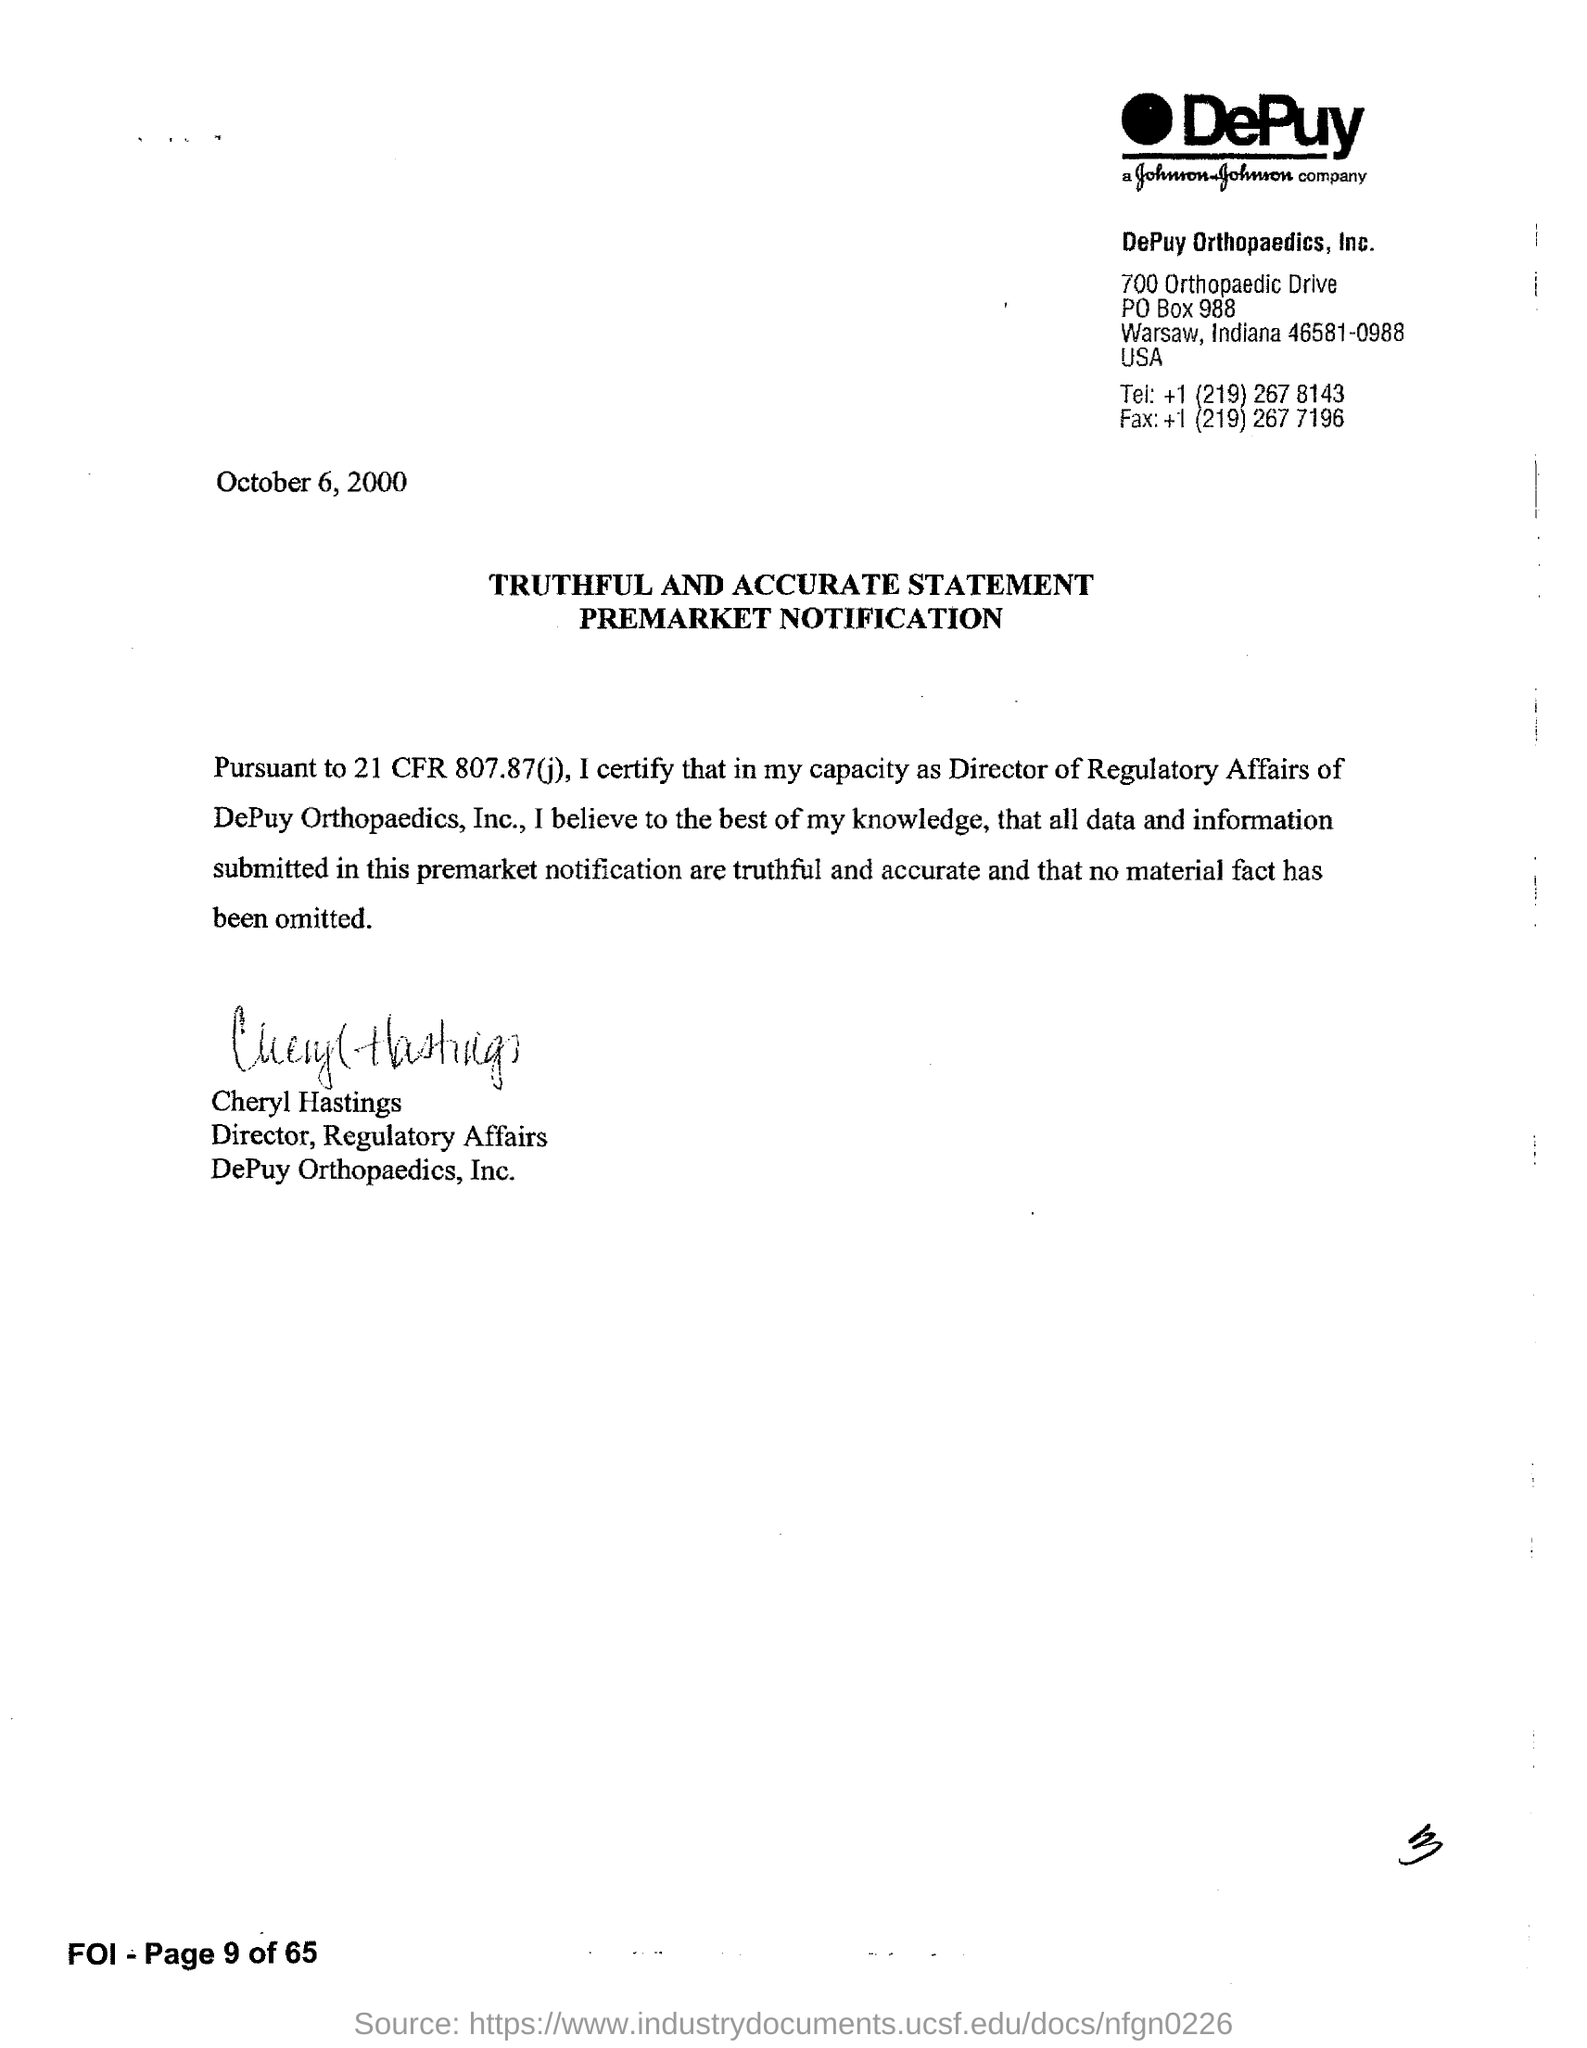List a handful of essential elements in this visual. Cheryl Hastings holds the designation of Director of Regulatory Affairs. The document was signed by Cheryl Hastings. The date mentioned in this document is October 6, 2000. The fax number for DePuy Orthopaedics, Inc. is +1 (219) 267 7196. 